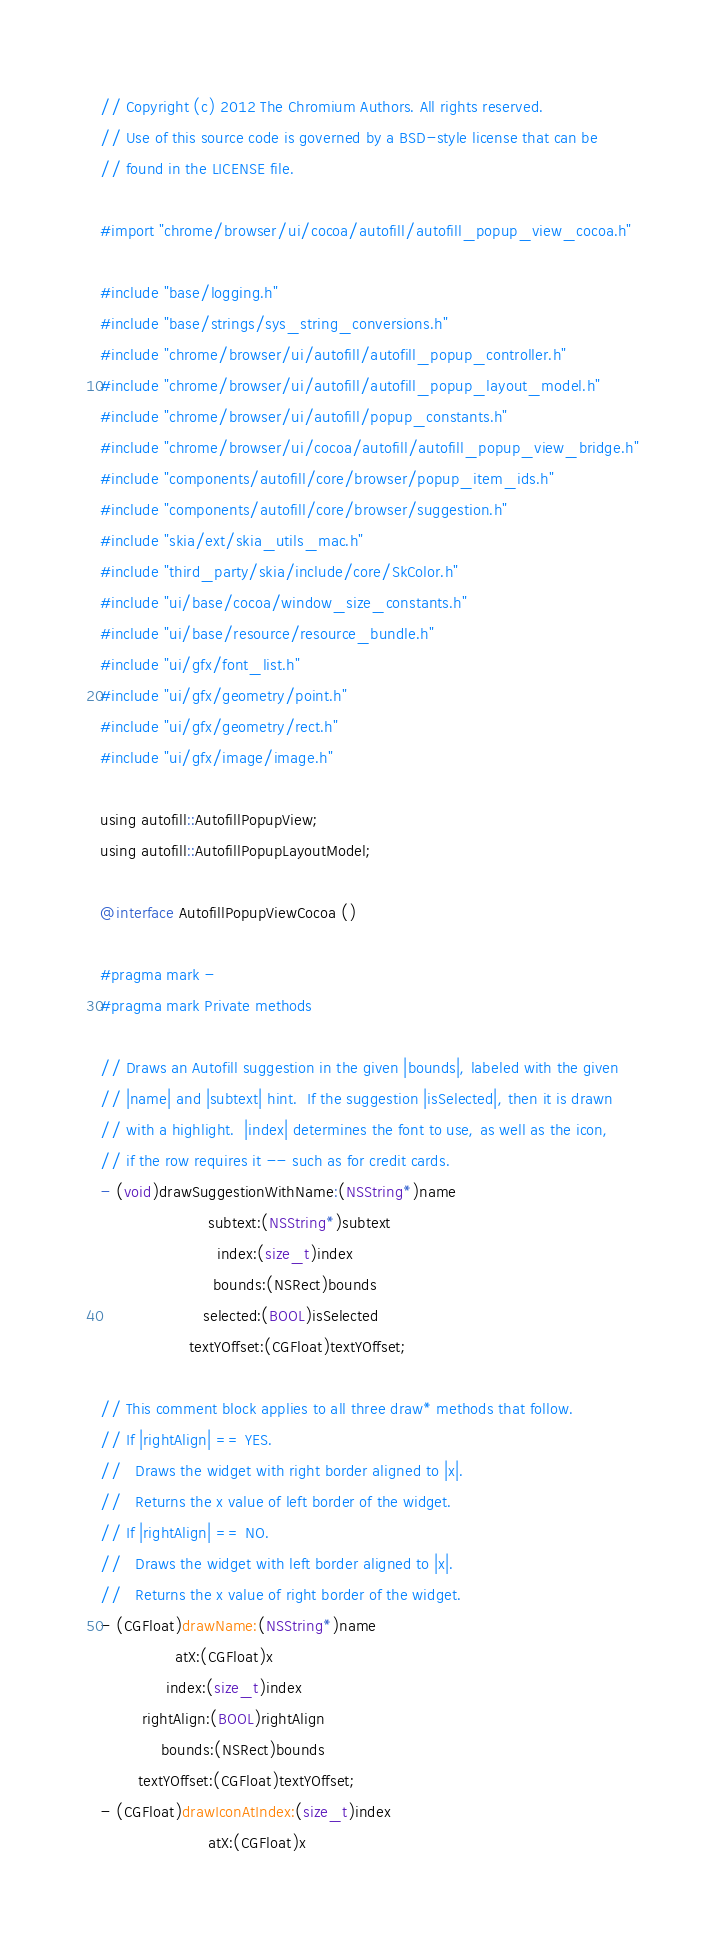<code> <loc_0><loc_0><loc_500><loc_500><_ObjectiveC_>// Copyright (c) 2012 The Chromium Authors. All rights reserved.
// Use of this source code is governed by a BSD-style license that can be
// found in the LICENSE file.

#import "chrome/browser/ui/cocoa/autofill/autofill_popup_view_cocoa.h"

#include "base/logging.h"
#include "base/strings/sys_string_conversions.h"
#include "chrome/browser/ui/autofill/autofill_popup_controller.h"
#include "chrome/browser/ui/autofill/autofill_popup_layout_model.h"
#include "chrome/browser/ui/autofill/popup_constants.h"
#include "chrome/browser/ui/cocoa/autofill/autofill_popup_view_bridge.h"
#include "components/autofill/core/browser/popup_item_ids.h"
#include "components/autofill/core/browser/suggestion.h"
#include "skia/ext/skia_utils_mac.h"
#include "third_party/skia/include/core/SkColor.h"
#include "ui/base/cocoa/window_size_constants.h"
#include "ui/base/resource/resource_bundle.h"
#include "ui/gfx/font_list.h"
#include "ui/gfx/geometry/point.h"
#include "ui/gfx/geometry/rect.h"
#include "ui/gfx/image/image.h"

using autofill::AutofillPopupView;
using autofill::AutofillPopupLayoutModel;

@interface AutofillPopupViewCocoa ()

#pragma mark -
#pragma mark Private methods

// Draws an Autofill suggestion in the given |bounds|, labeled with the given
// |name| and |subtext| hint.  If the suggestion |isSelected|, then it is drawn
// with a highlight.  |index| determines the font to use, as well as the icon,
// if the row requires it -- such as for credit cards.
- (void)drawSuggestionWithName:(NSString*)name
                       subtext:(NSString*)subtext
                         index:(size_t)index
                        bounds:(NSRect)bounds
                      selected:(BOOL)isSelected
                   textYOffset:(CGFloat)textYOffset;

// This comment block applies to all three draw* methods that follow.
// If |rightAlign| == YES.
//   Draws the widget with right border aligned to |x|.
//   Returns the x value of left border of the widget.
// If |rightAlign| == NO.
//   Draws the widget with left border aligned to |x|.
//   Returns the x value of right border of the widget.
- (CGFloat)drawName:(NSString*)name
                atX:(CGFloat)x
              index:(size_t)index
         rightAlign:(BOOL)rightAlign
             bounds:(NSRect)bounds
        textYOffset:(CGFloat)textYOffset;
- (CGFloat)drawIconAtIndex:(size_t)index
                       atX:(CGFloat)x</code> 